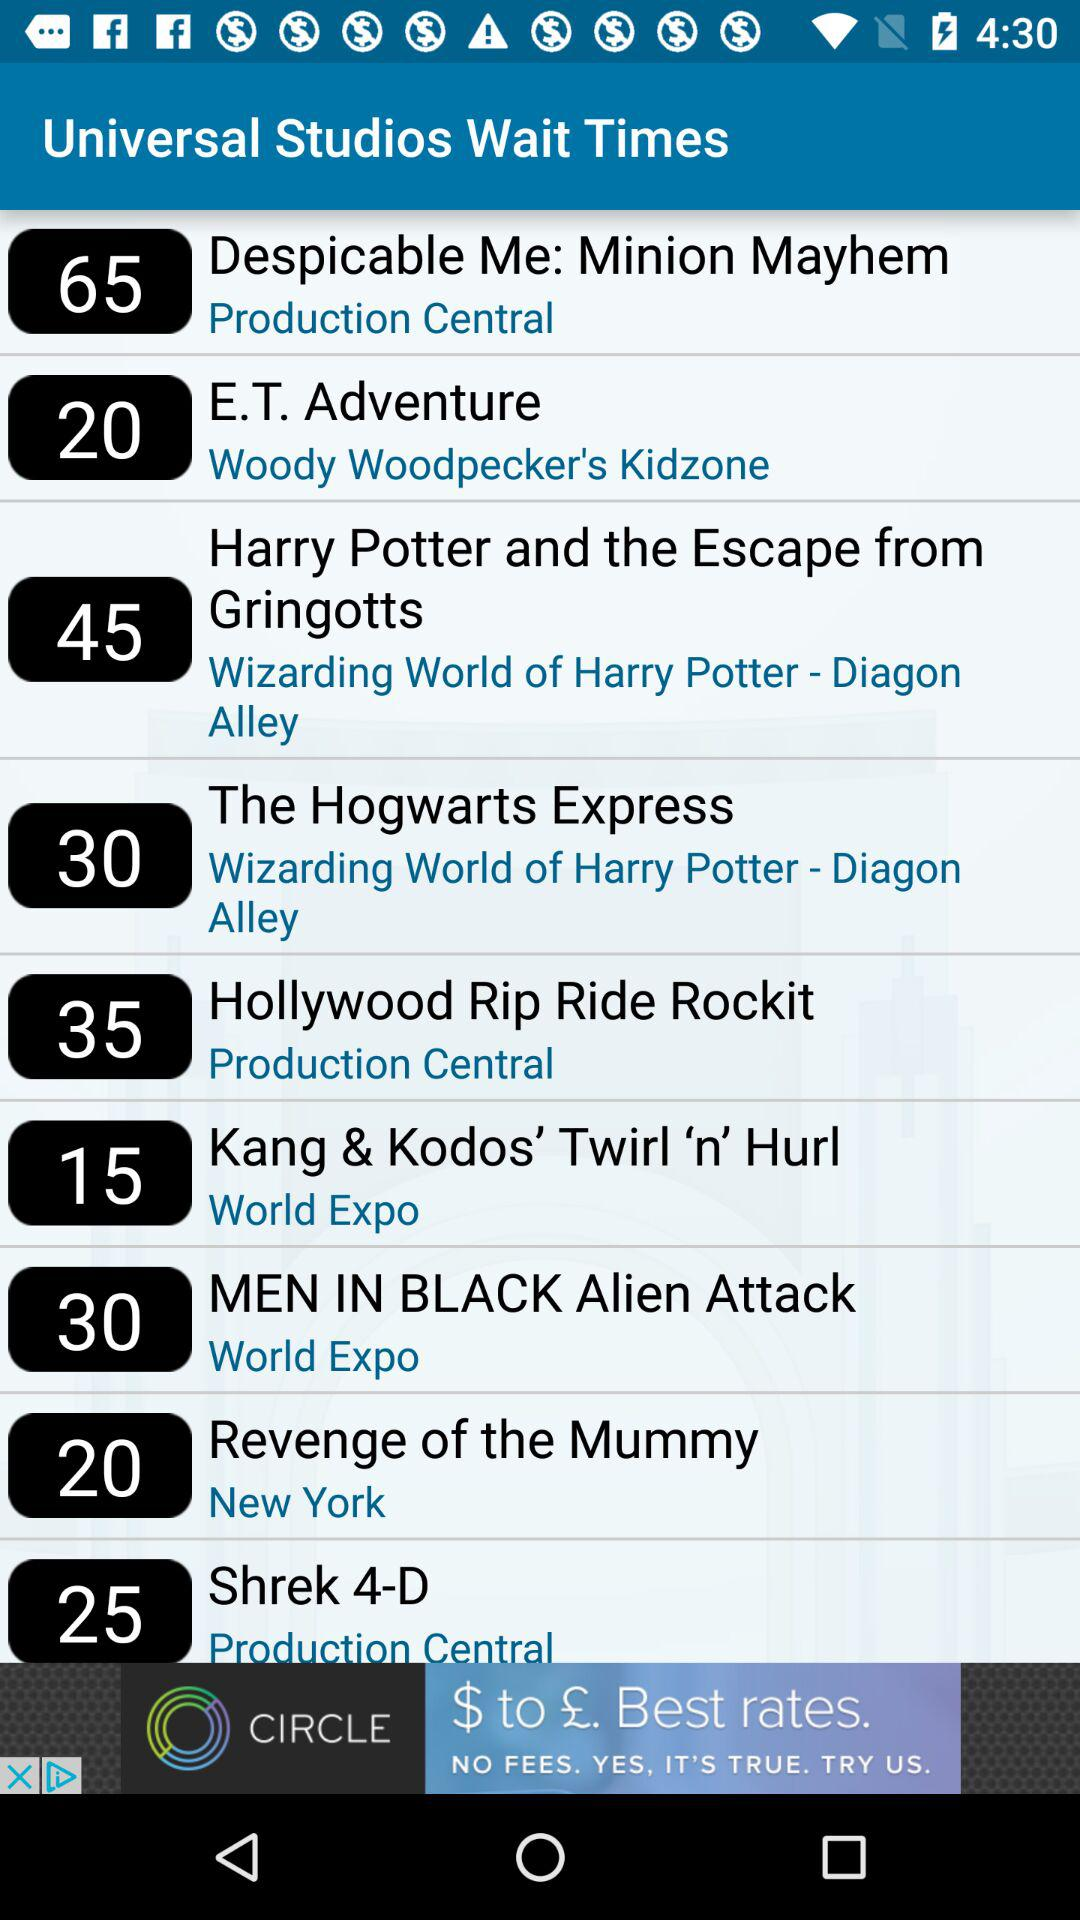How many rides are in the Harry Potter area?
Answer the question using a single word or phrase. 2 